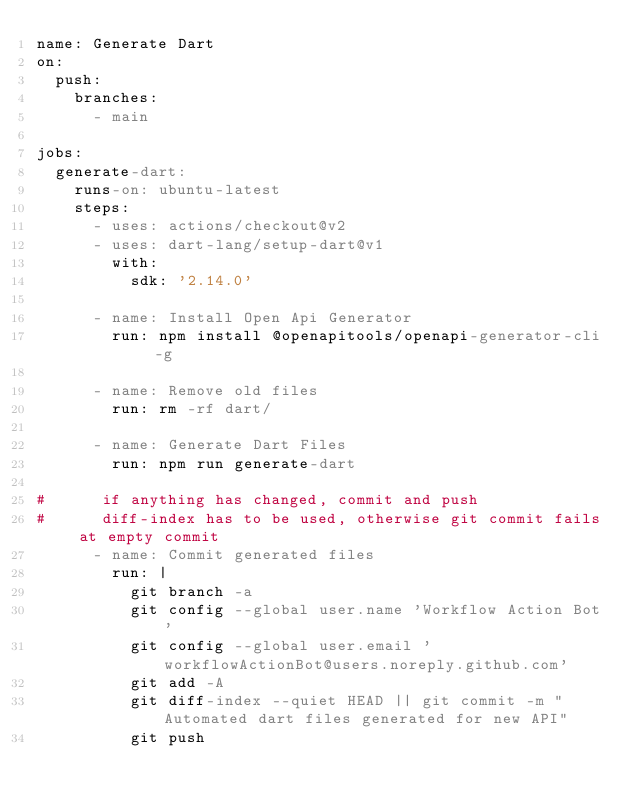<code> <loc_0><loc_0><loc_500><loc_500><_YAML_>name: Generate Dart
on:
  push:
    branches:
      - main

jobs:
  generate-dart:
    runs-on: ubuntu-latest
    steps:
      - uses: actions/checkout@v2
      - uses: dart-lang/setup-dart@v1
        with:
          sdk: '2.14.0'

      - name: Install Open Api Generator
        run: npm install @openapitools/openapi-generator-cli -g

      - name: Remove old files
        run: rm -rf dart/

      - name: Generate Dart Files
        run: npm run generate-dart

#      if anything has changed, commit and push
#      diff-index has to be used, otherwise git commit fails at empty commit
      - name: Commit generated files
        run: |
          git branch -a
          git config --global user.name 'Workflow Action Bot'
          git config --global user.email 'workflowActionBot@users.noreply.github.com'
          git add -A
          git diff-index --quiet HEAD || git commit -m "Automated dart files generated for new API"
          git push
</code> 